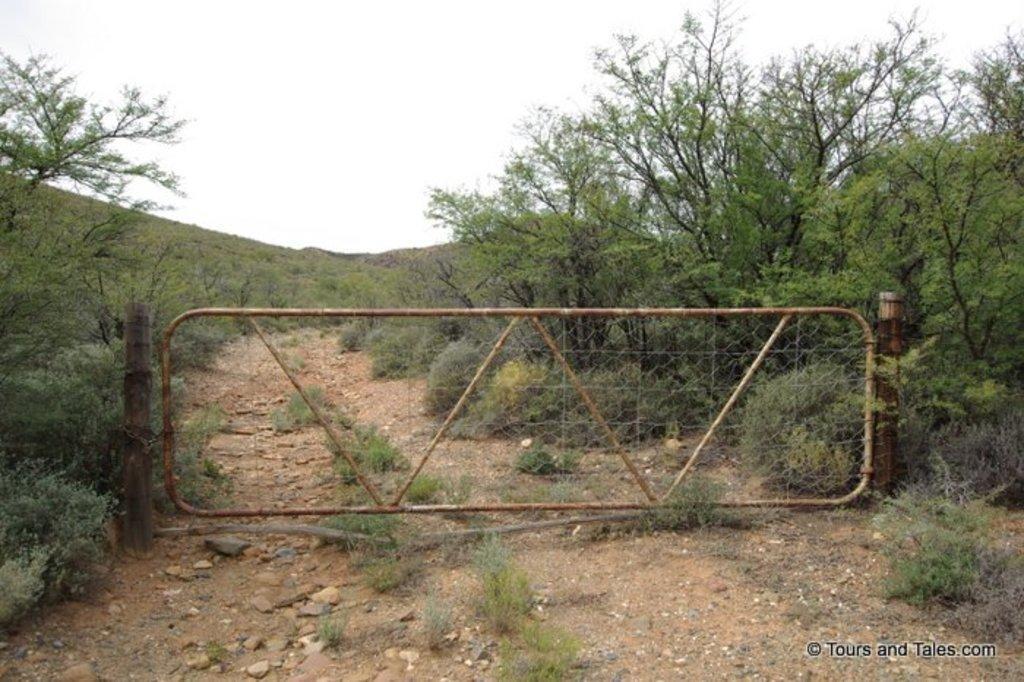Please provide a concise description of this image. In this image, we can see the ground. We can see some grass, plants and trees. We can also see a metallic object with some poles. We can also see the sky. We can also see some text on the bottom right corner. 